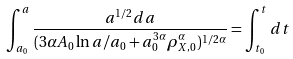<formula> <loc_0><loc_0><loc_500><loc_500>\int ^ { a } _ { a _ { 0 } } \frac { a ^ { 1 / 2 } d a } { ( 3 \alpha A _ { 0 } \ln a / a _ { 0 } + a _ { 0 } ^ { 3 \alpha } \rho _ { X , 0 } ^ { \alpha } ) ^ { 1 / 2 \alpha } } = \int ^ { t } _ { t _ { 0 } } d t</formula> 